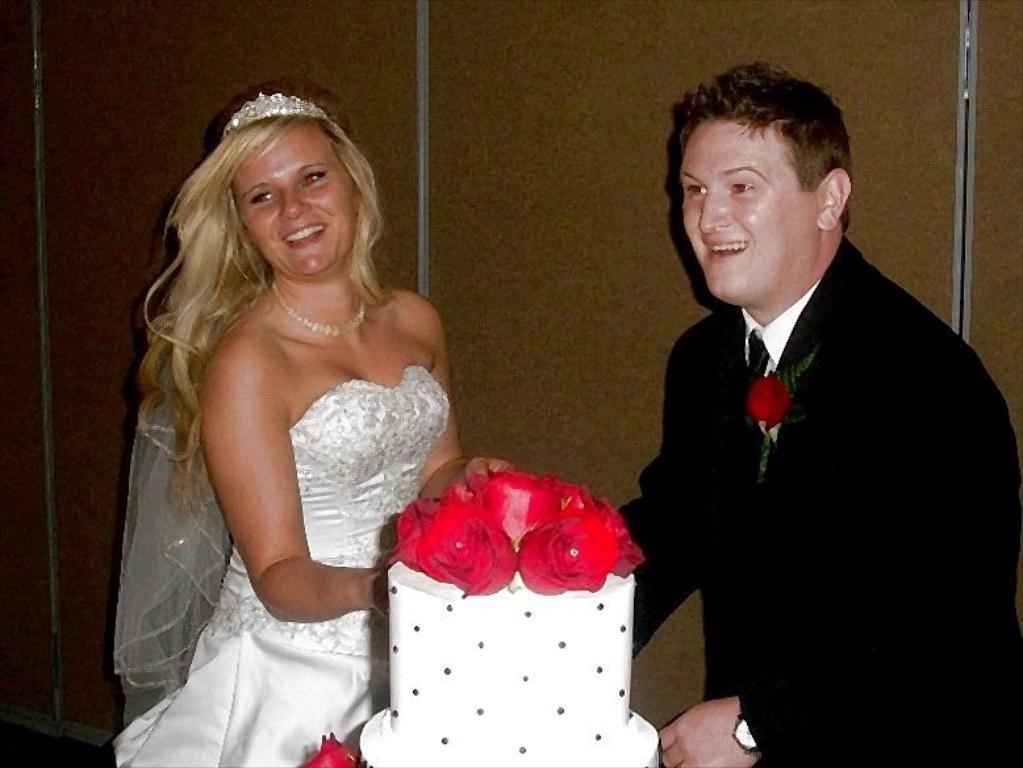What is happening in the center of the image? There are couples standing in the center of the image. What object is in front of the couples? There is a cake in front of the couples. What can be seen in the background of the image? There is a wall in the background of the image. Is there a rifle visible in the image? No, there is no rifle present in the image. 